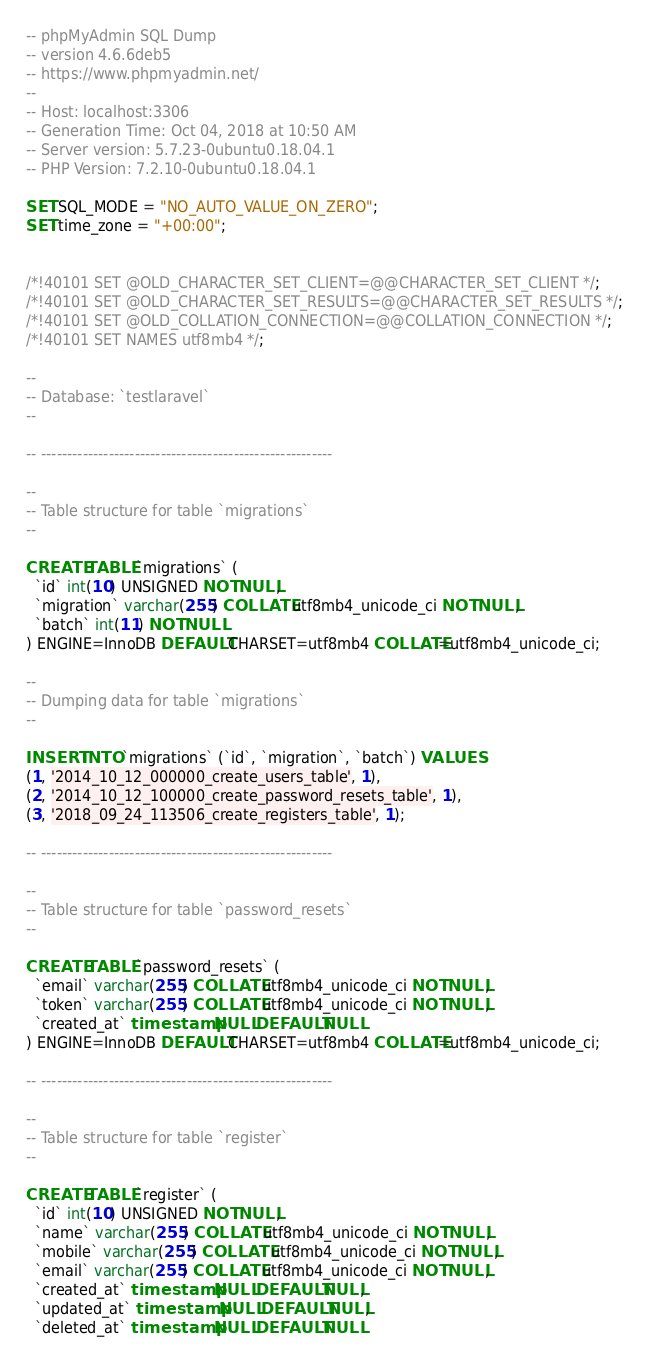Convert code to text. <code><loc_0><loc_0><loc_500><loc_500><_SQL_>-- phpMyAdmin SQL Dump
-- version 4.6.6deb5
-- https://www.phpmyadmin.net/
--
-- Host: localhost:3306
-- Generation Time: Oct 04, 2018 at 10:50 AM
-- Server version: 5.7.23-0ubuntu0.18.04.1
-- PHP Version: 7.2.10-0ubuntu0.18.04.1

SET SQL_MODE = "NO_AUTO_VALUE_ON_ZERO";
SET time_zone = "+00:00";


/*!40101 SET @OLD_CHARACTER_SET_CLIENT=@@CHARACTER_SET_CLIENT */;
/*!40101 SET @OLD_CHARACTER_SET_RESULTS=@@CHARACTER_SET_RESULTS */;
/*!40101 SET @OLD_COLLATION_CONNECTION=@@COLLATION_CONNECTION */;
/*!40101 SET NAMES utf8mb4 */;

--
-- Database: `testlaravel`
--

-- --------------------------------------------------------

--
-- Table structure for table `migrations`
--

CREATE TABLE `migrations` (
  `id` int(10) UNSIGNED NOT NULL,
  `migration` varchar(255) COLLATE utf8mb4_unicode_ci NOT NULL,
  `batch` int(11) NOT NULL
) ENGINE=InnoDB DEFAULT CHARSET=utf8mb4 COLLATE=utf8mb4_unicode_ci;

--
-- Dumping data for table `migrations`
--

INSERT INTO `migrations` (`id`, `migration`, `batch`) VALUES
(1, '2014_10_12_000000_create_users_table', 1),
(2, '2014_10_12_100000_create_password_resets_table', 1),
(3, '2018_09_24_113506_create_registers_table', 1);

-- --------------------------------------------------------

--
-- Table structure for table `password_resets`
--

CREATE TABLE `password_resets` (
  `email` varchar(255) COLLATE utf8mb4_unicode_ci NOT NULL,
  `token` varchar(255) COLLATE utf8mb4_unicode_ci NOT NULL,
  `created_at` timestamp NULL DEFAULT NULL
) ENGINE=InnoDB DEFAULT CHARSET=utf8mb4 COLLATE=utf8mb4_unicode_ci;

-- --------------------------------------------------------

--
-- Table structure for table `register`
--

CREATE TABLE `register` (
  `id` int(10) UNSIGNED NOT NULL,
  `name` varchar(255) COLLATE utf8mb4_unicode_ci NOT NULL,
  `mobile` varchar(255) COLLATE utf8mb4_unicode_ci NOT NULL,
  `email` varchar(255) COLLATE utf8mb4_unicode_ci NOT NULL,
  `created_at` timestamp NULL DEFAULT NULL,
  `updated_at` timestamp NULL DEFAULT NULL,
  `deleted_at` timestamp NULL DEFAULT NULL</code> 